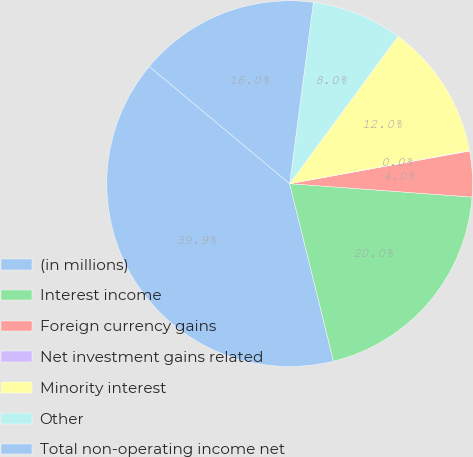<chart> <loc_0><loc_0><loc_500><loc_500><pie_chart><fcel>(in millions)<fcel>Interest income<fcel>Foreign currency gains<fcel>Net investment gains related<fcel>Minority interest<fcel>Other<fcel>Total non-operating income net<nl><fcel>39.93%<fcel>19.98%<fcel>4.03%<fcel>0.04%<fcel>12.01%<fcel>8.02%<fcel>16.0%<nl></chart> 